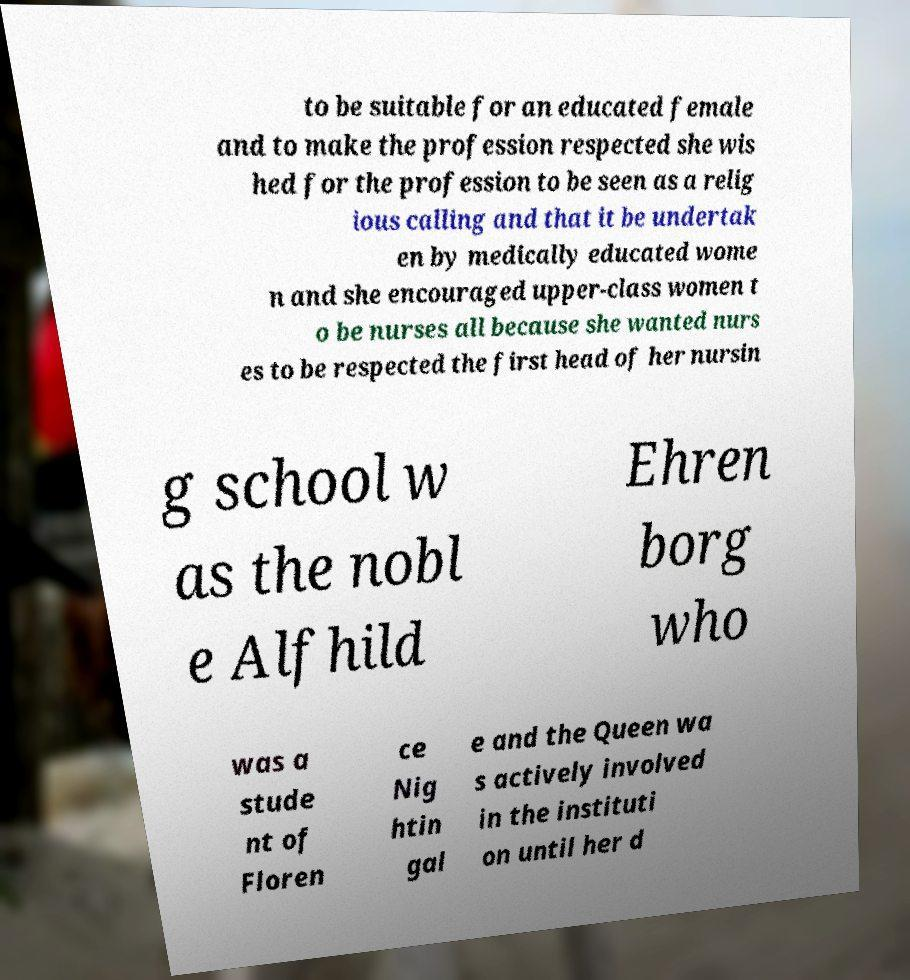Please read and relay the text visible in this image. What does it say? to be suitable for an educated female and to make the profession respected she wis hed for the profession to be seen as a relig ious calling and that it be undertak en by medically educated wome n and she encouraged upper-class women t o be nurses all because she wanted nurs es to be respected the first head of her nursin g school w as the nobl e Alfhild Ehren borg who was a stude nt of Floren ce Nig htin gal e and the Queen wa s actively involved in the instituti on until her d 